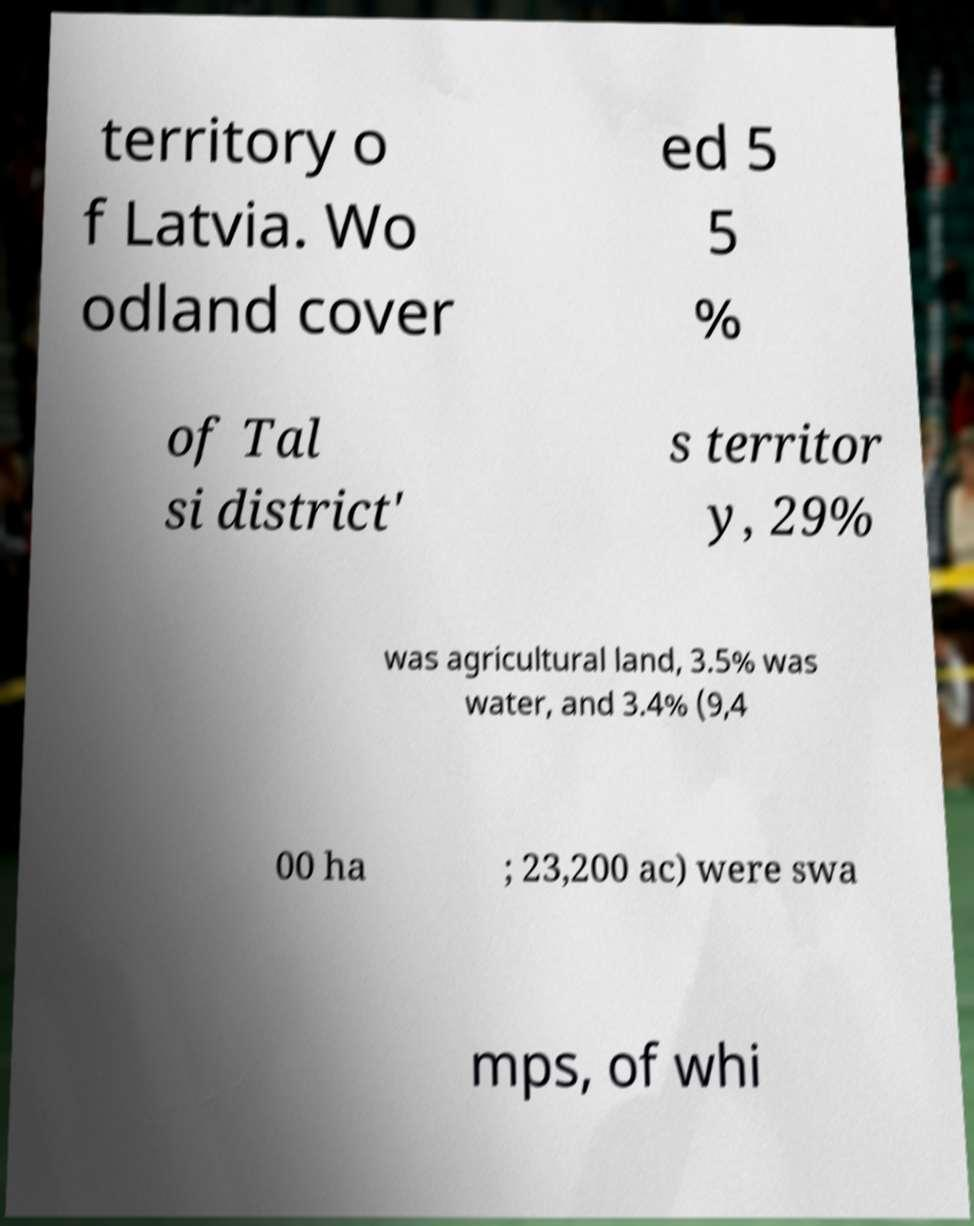I need the written content from this picture converted into text. Can you do that? territory o f Latvia. Wo odland cover ed 5 5 % of Tal si district' s territor y, 29% was agricultural land, 3.5% was water, and 3.4% (9,4 00 ha ; 23,200 ac) were swa mps, of whi 